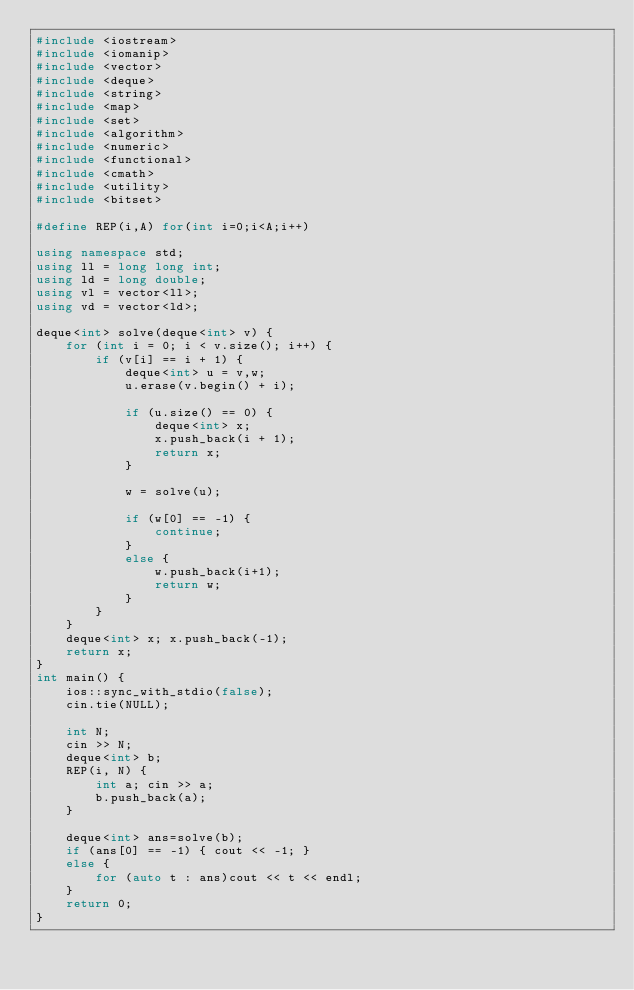Convert code to text. <code><loc_0><loc_0><loc_500><loc_500><_C++_>#include <iostream>
#include <iomanip>
#include <vector>
#include <deque>
#include <string>
#include <map>
#include <set>
#include <algorithm>
#include <numeric>
#include <functional>
#include <cmath>
#include <utility>
#include <bitset>

#define REP(i,A) for(int i=0;i<A;i++)

using namespace std;
using ll = long long int;
using ld = long double;
using vl = vector<ll>;
using vd = vector<ld>;

deque<int> solve(deque<int> v) {
	for (int i = 0; i < v.size(); i++) {
		if (v[i] == i + 1) {
			deque<int> u = v,w;
			u.erase(v.begin() + i);

			if (u.size() == 0) {
				deque<int> x;
				x.push_back(i + 1);
				return x;
			}

			w = solve(u);

			if (w[0] == -1) {
				continue;
			}
			else {
				w.push_back(i+1);
				return w;
			}
		}
	}
	deque<int> x; x.push_back(-1);
	return x;
}
int main() {
	ios::sync_with_stdio(false);
	cin.tie(NULL);

	int N;
	cin >> N;
	deque<int> b;
	REP(i, N) {
		int a; cin >> a;
		b.push_back(a);
	}

	deque<int> ans=solve(b);
	if (ans[0] == -1) { cout << -1; }
	else {
		for (auto t : ans)cout << t << endl;
	}
	return 0;
}</code> 